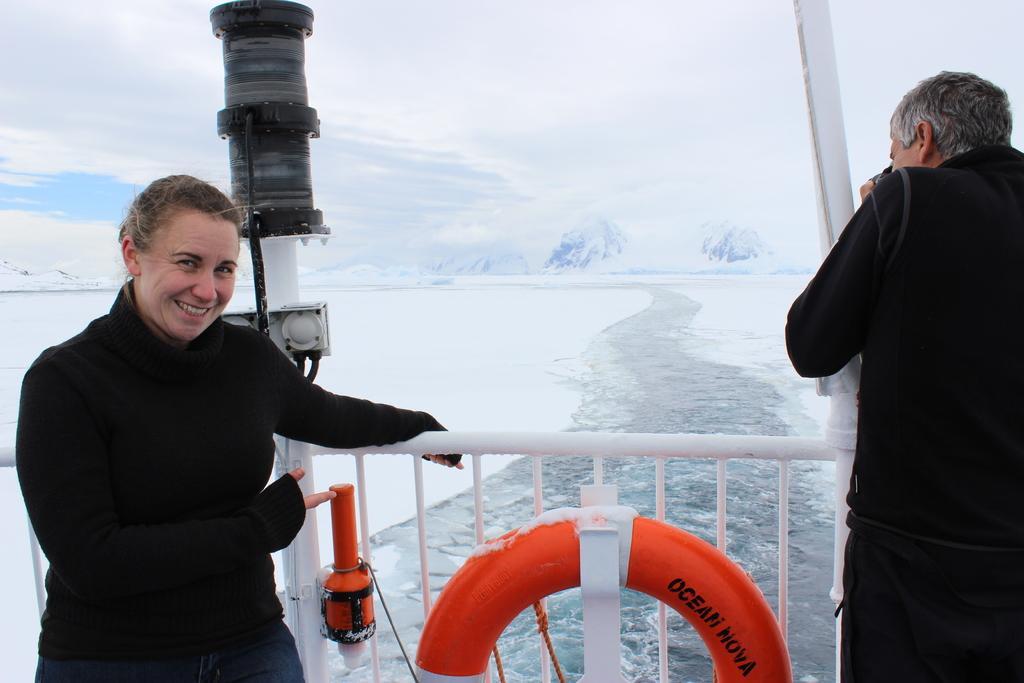Describe this image in one or two sentences. In this picture there is a man on the right side of the image and there is a woman on the left side of the image, it seems to be they are standing in the ship and there is water in the center of the image and there is snow on the right and left side of the image. 